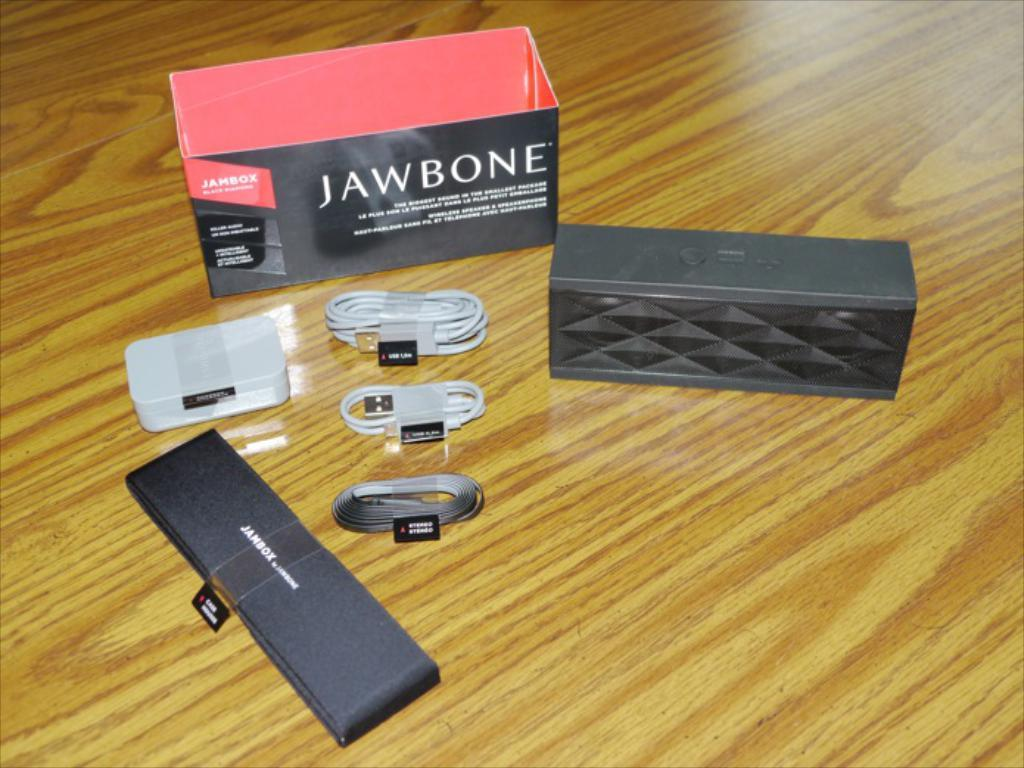What objects are present in the image? There are boxes and data cables with stickers in the image. How are the boxes and data cables arranged in the image? The boxes and data cables are placed on a platform. Can you tell me how many flies are sitting on the boxes in the image? There are no flies present in the image. What month is it in the image? The month cannot be determined from the image, as it does not contain any information about the time of year. 